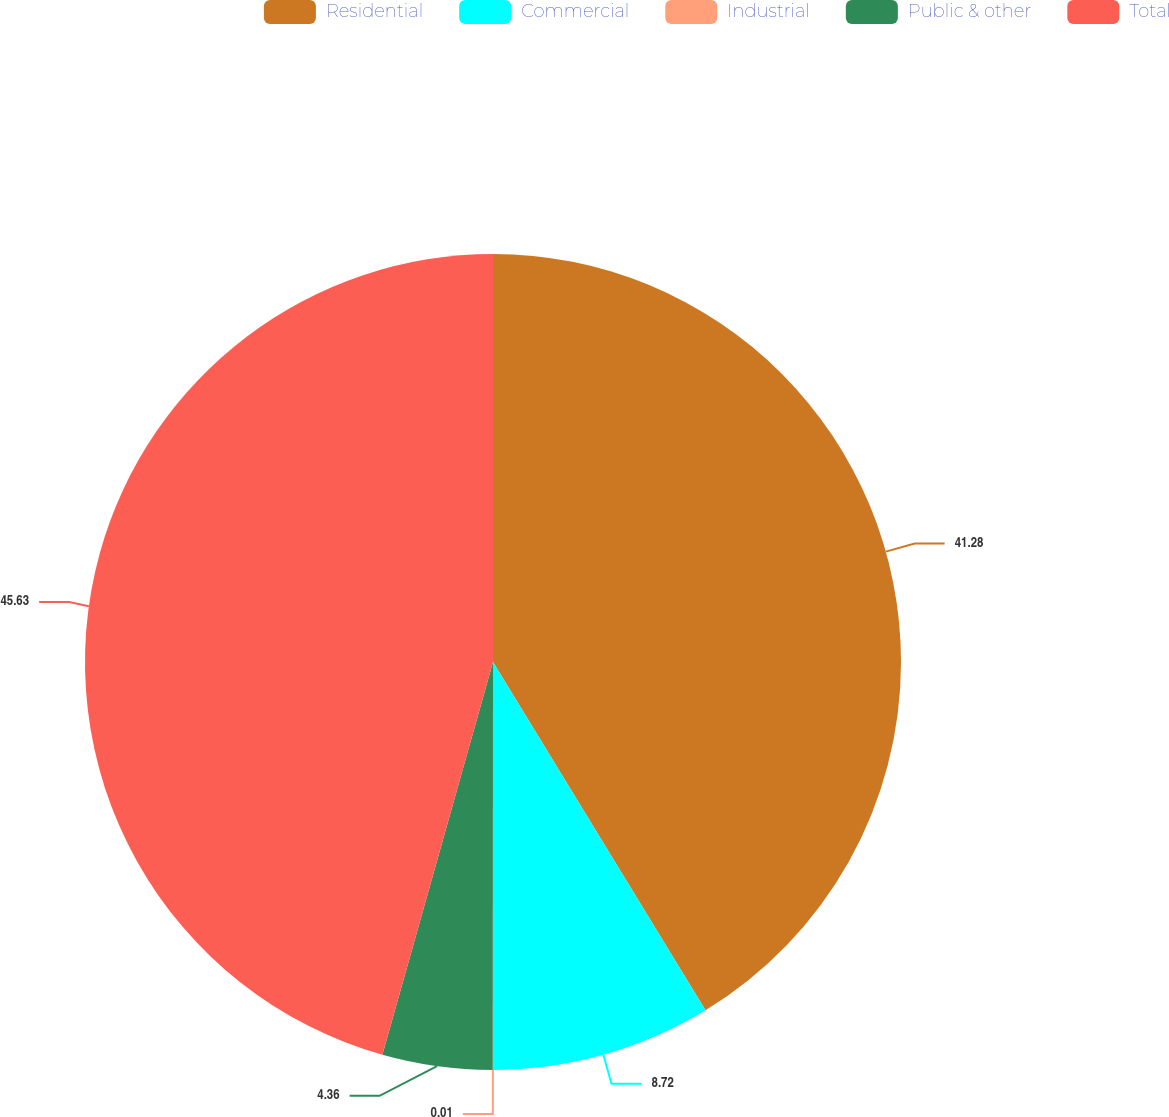<chart> <loc_0><loc_0><loc_500><loc_500><pie_chart><fcel>Residential<fcel>Commercial<fcel>Industrial<fcel>Public & other<fcel>Total<nl><fcel>41.28%<fcel>8.72%<fcel>0.01%<fcel>4.36%<fcel>45.63%<nl></chart> 